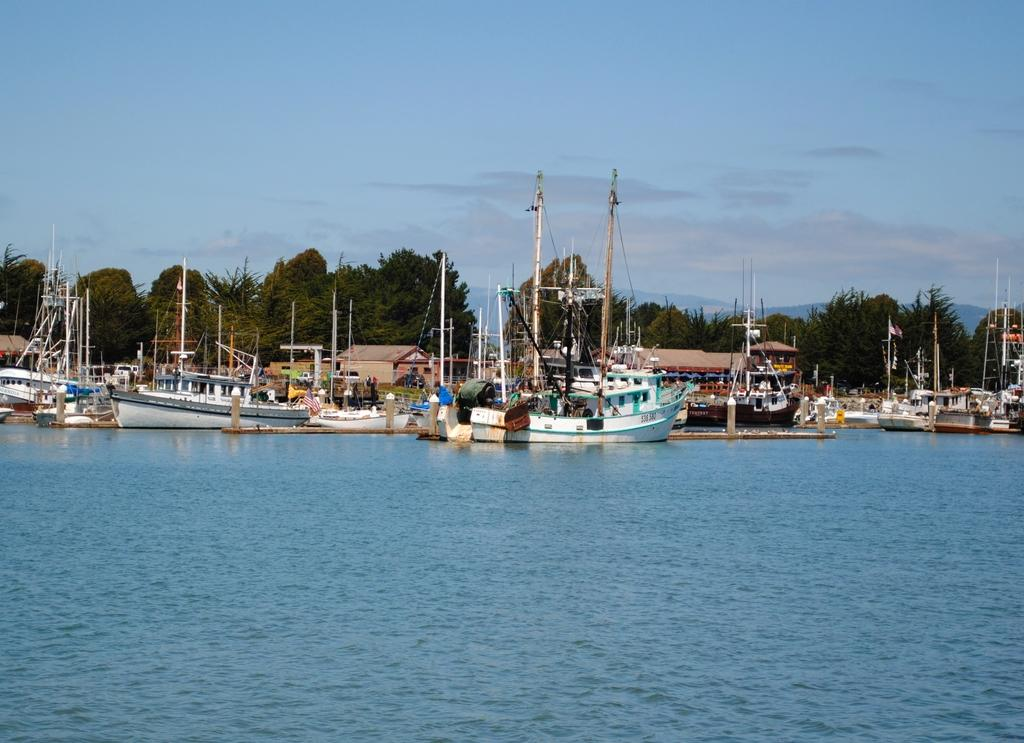What is visible in the image? Water, ships, trees, and clouds are visible in the image. Can you describe the ships in the image? The ships are in the water, but their specific features cannot be determined from the image. What is visible in the background of the image? Trees and clouds are visible in the background of the image. Can you tell me how many people are talking under the veil in the image? There is no veil or people talking present in the image. What type of leaves are falling from the trees in the image? There is no indication of leaves falling from the trees in the image. 